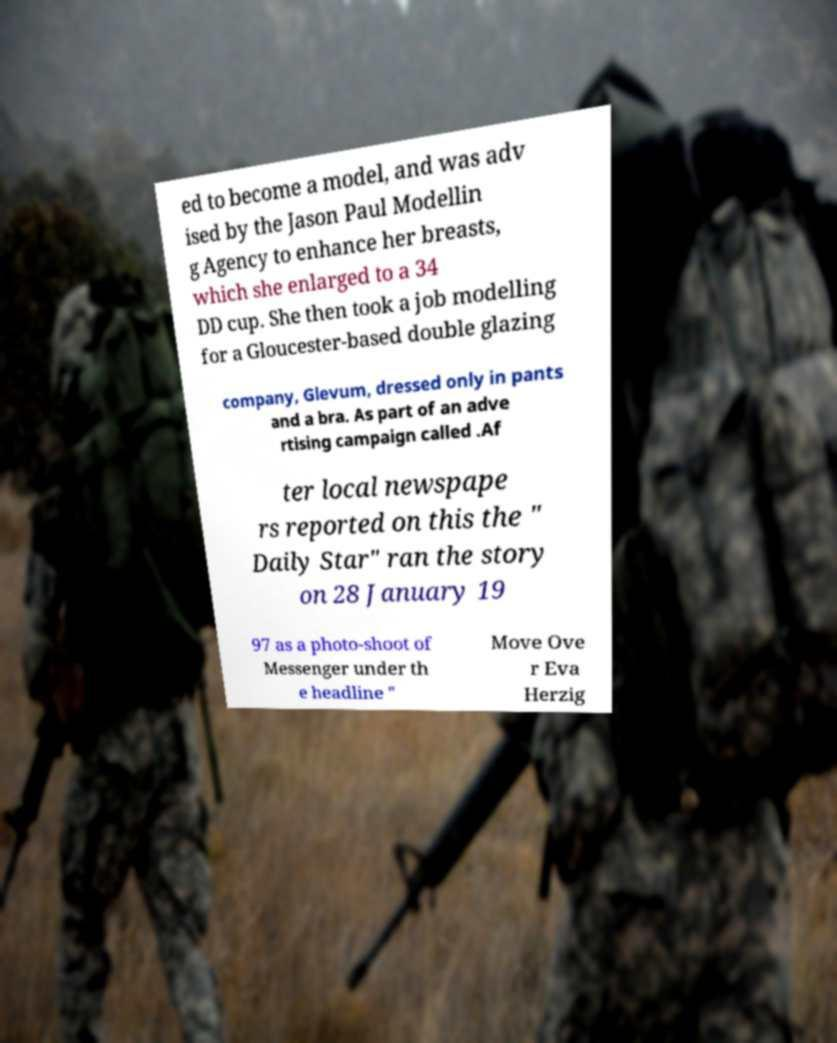Can you accurately transcribe the text from the provided image for me? ed to become a model, and was adv ised by the Jason Paul Modellin g Agency to enhance her breasts, which she enlarged to a 34 DD cup. She then took a job modelling for a Gloucester-based double glazing company, Glevum, dressed only in pants and a bra. As part of an adve rtising campaign called .Af ter local newspape rs reported on this the " Daily Star" ran the story on 28 January 19 97 as a photo-shoot of Messenger under th e headline " Move Ove r Eva Herzig 